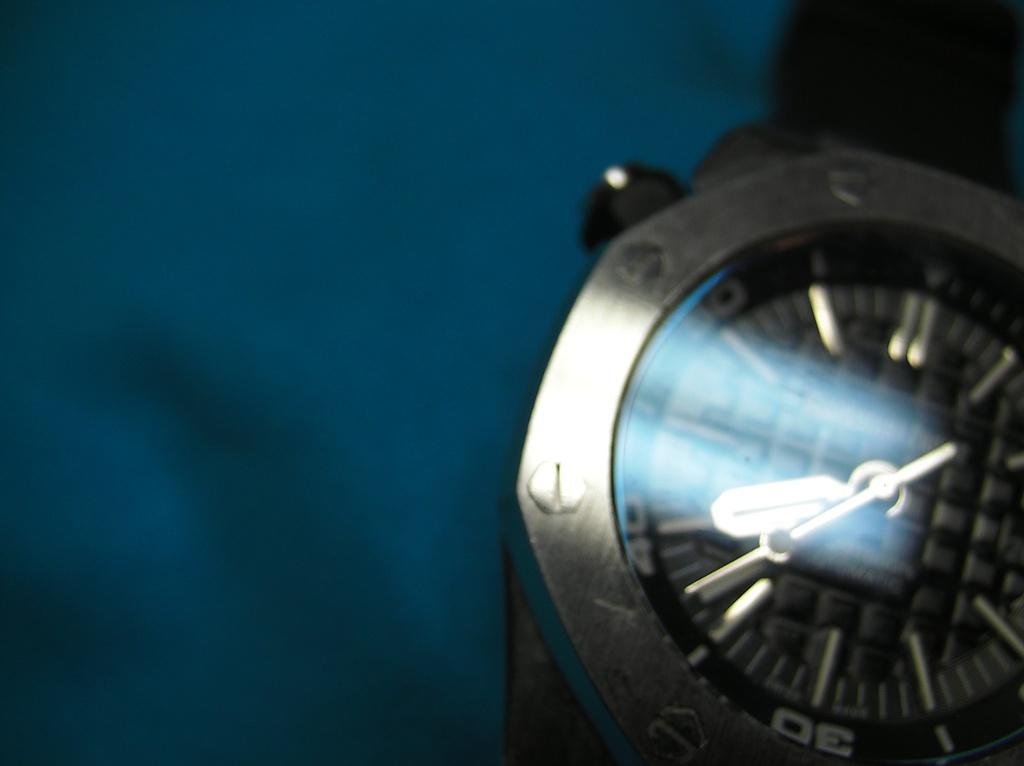<image>
Create a compact narrative representing the image presented. A watch face has the number 30 at the bottom of it. 